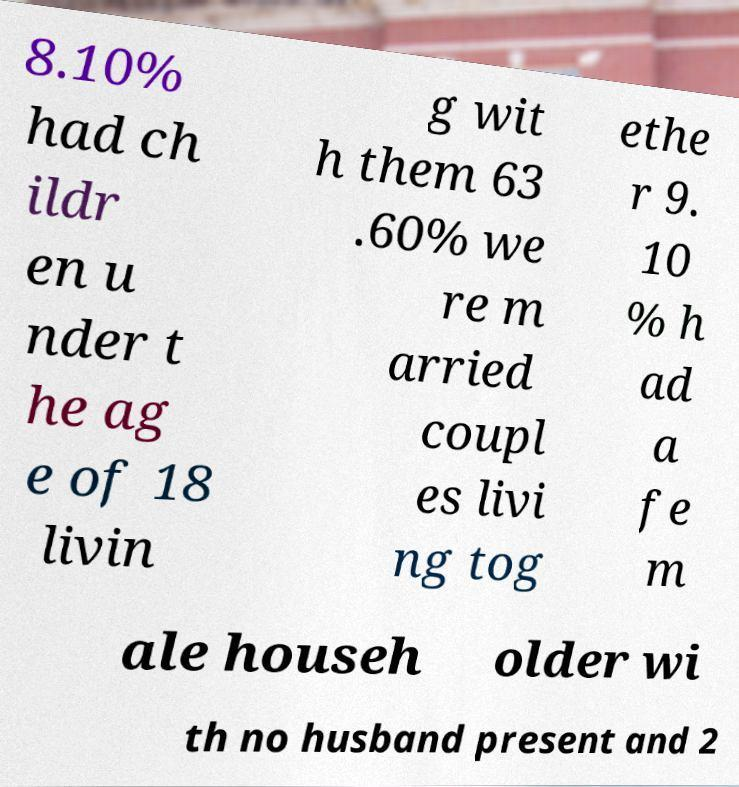What messages or text are displayed in this image? I need them in a readable, typed format. 8.10% had ch ildr en u nder t he ag e of 18 livin g wit h them 63 .60% we re m arried coupl es livi ng tog ethe r 9. 10 % h ad a fe m ale househ older wi th no husband present and 2 